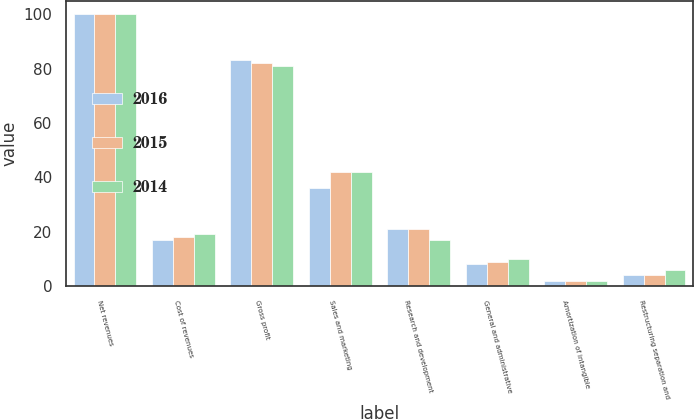Convert chart to OTSL. <chart><loc_0><loc_0><loc_500><loc_500><stacked_bar_chart><ecel><fcel>Net revenues<fcel>Cost of revenues<fcel>Gross profit<fcel>Sales and marketing<fcel>Research and development<fcel>General and administrative<fcel>Amortization of intangible<fcel>Restructuring separation and<nl><fcel>2016<fcel>100<fcel>17<fcel>83<fcel>36<fcel>21<fcel>8<fcel>2<fcel>4<nl><fcel>2015<fcel>100<fcel>18<fcel>82<fcel>42<fcel>21<fcel>9<fcel>2<fcel>4<nl><fcel>2014<fcel>100<fcel>19<fcel>81<fcel>42<fcel>17<fcel>10<fcel>2<fcel>6<nl></chart> 